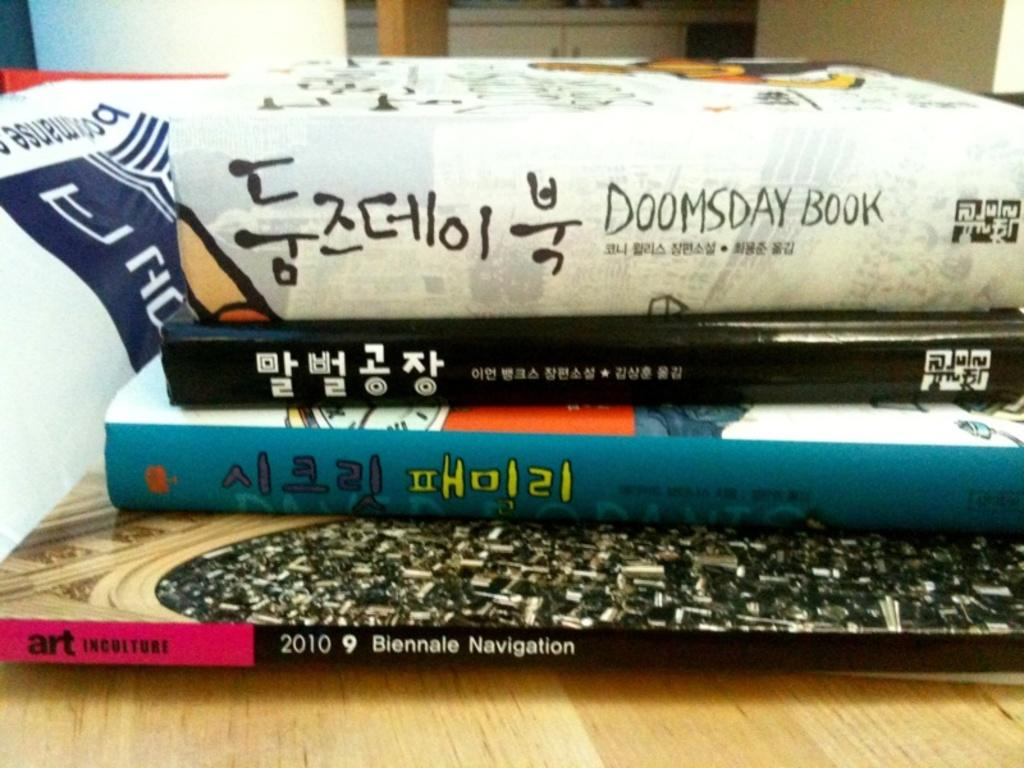<image>
Offer a succinct explanation of the picture presented. a few books, one with the year 2010 on it 